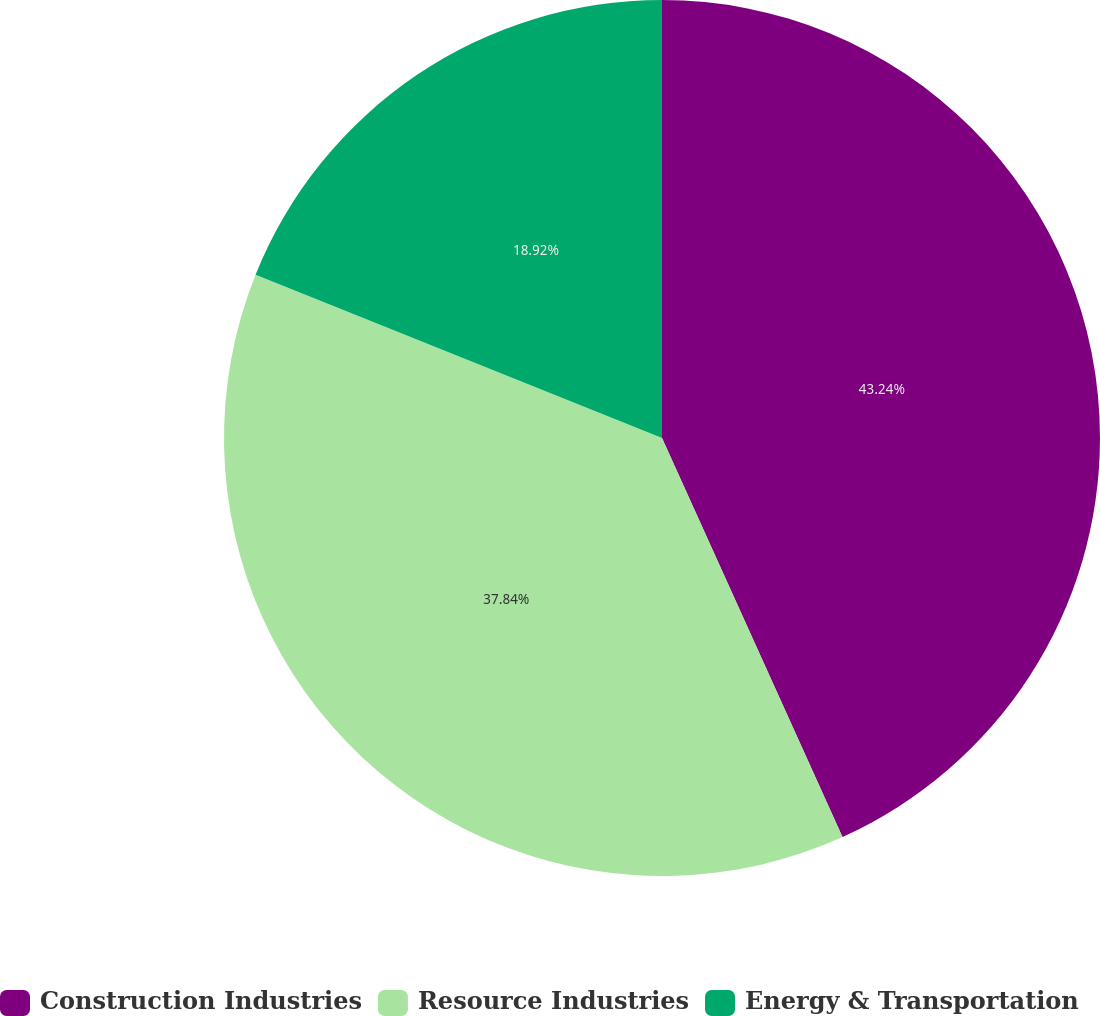Convert chart. <chart><loc_0><loc_0><loc_500><loc_500><pie_chart><fcel>Construction Industries<fcel>Resource Industries<fcel>Energy & Transportation<nl><fcel>43.24%<fcel>37.84%<fcel>18.92%<nl></chart> 